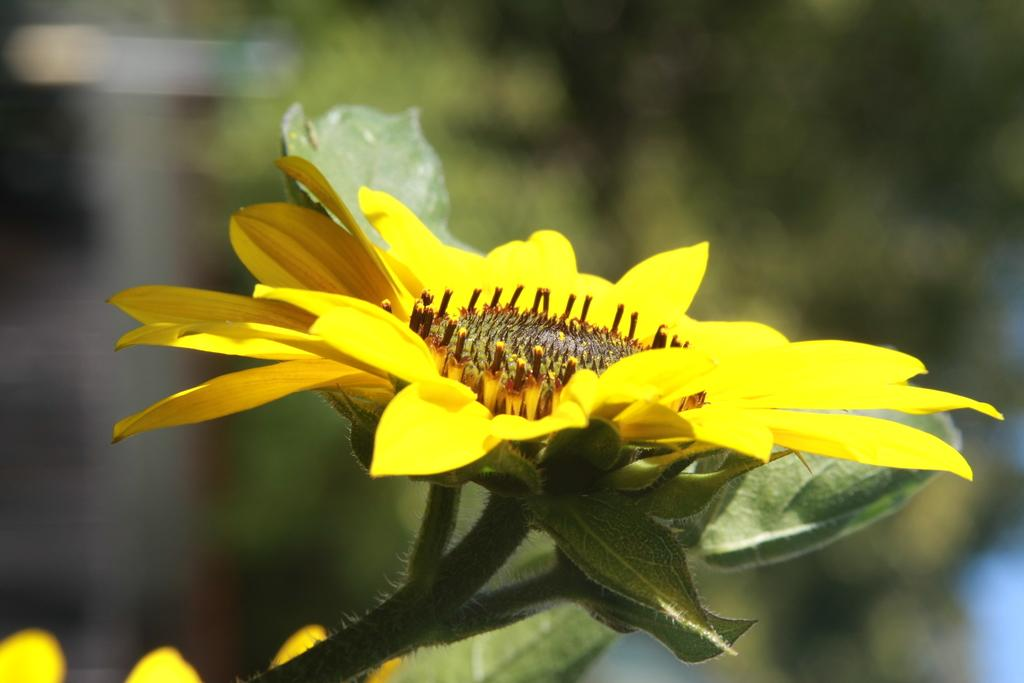What is present in the image? There is a plant in the image. What specific feature of the plant can be observed? The plant has flowers. Can you describe the background of the image? The background of the image is blurry. What type of guide can be seen leading a group of bikes in the image? There is no guide or group of bikes present in the image; it features a plant with flowers and a blurry background. 